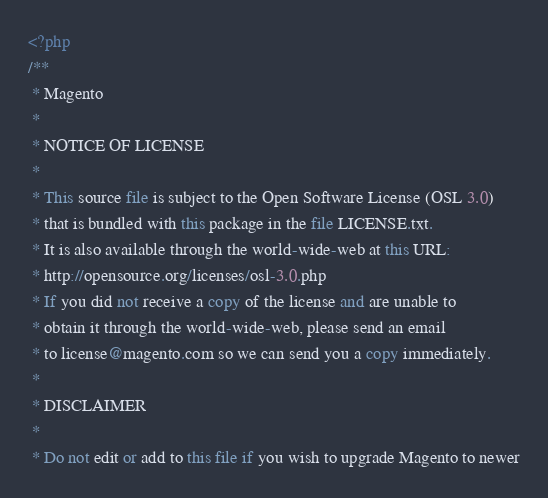<code> <loc_0><loc_0><loc_500><loc_500><_PHP_><?php
/**
 * Magento
 *
 * NOTICE OF LICENSE
 *
 * This source file is subject to the Open Software License (OSL 3.0)
 * that is bundled with this package in the file LICENSE.txt.
 * It is also available through the world-wide-web at this URL:
 * http://opensource.org/licenses/osl-3.0.php
 * If you did not receive a copy of the license and are unable to
 * obtain it through the world-wide-web, please send an email
 * to license@magento.com so we can send you a copy immediately.
 *
 * DISCLAIMER
 *
 * Do not edit or add to this file if you wish to upgrade Magento to newer</code> 